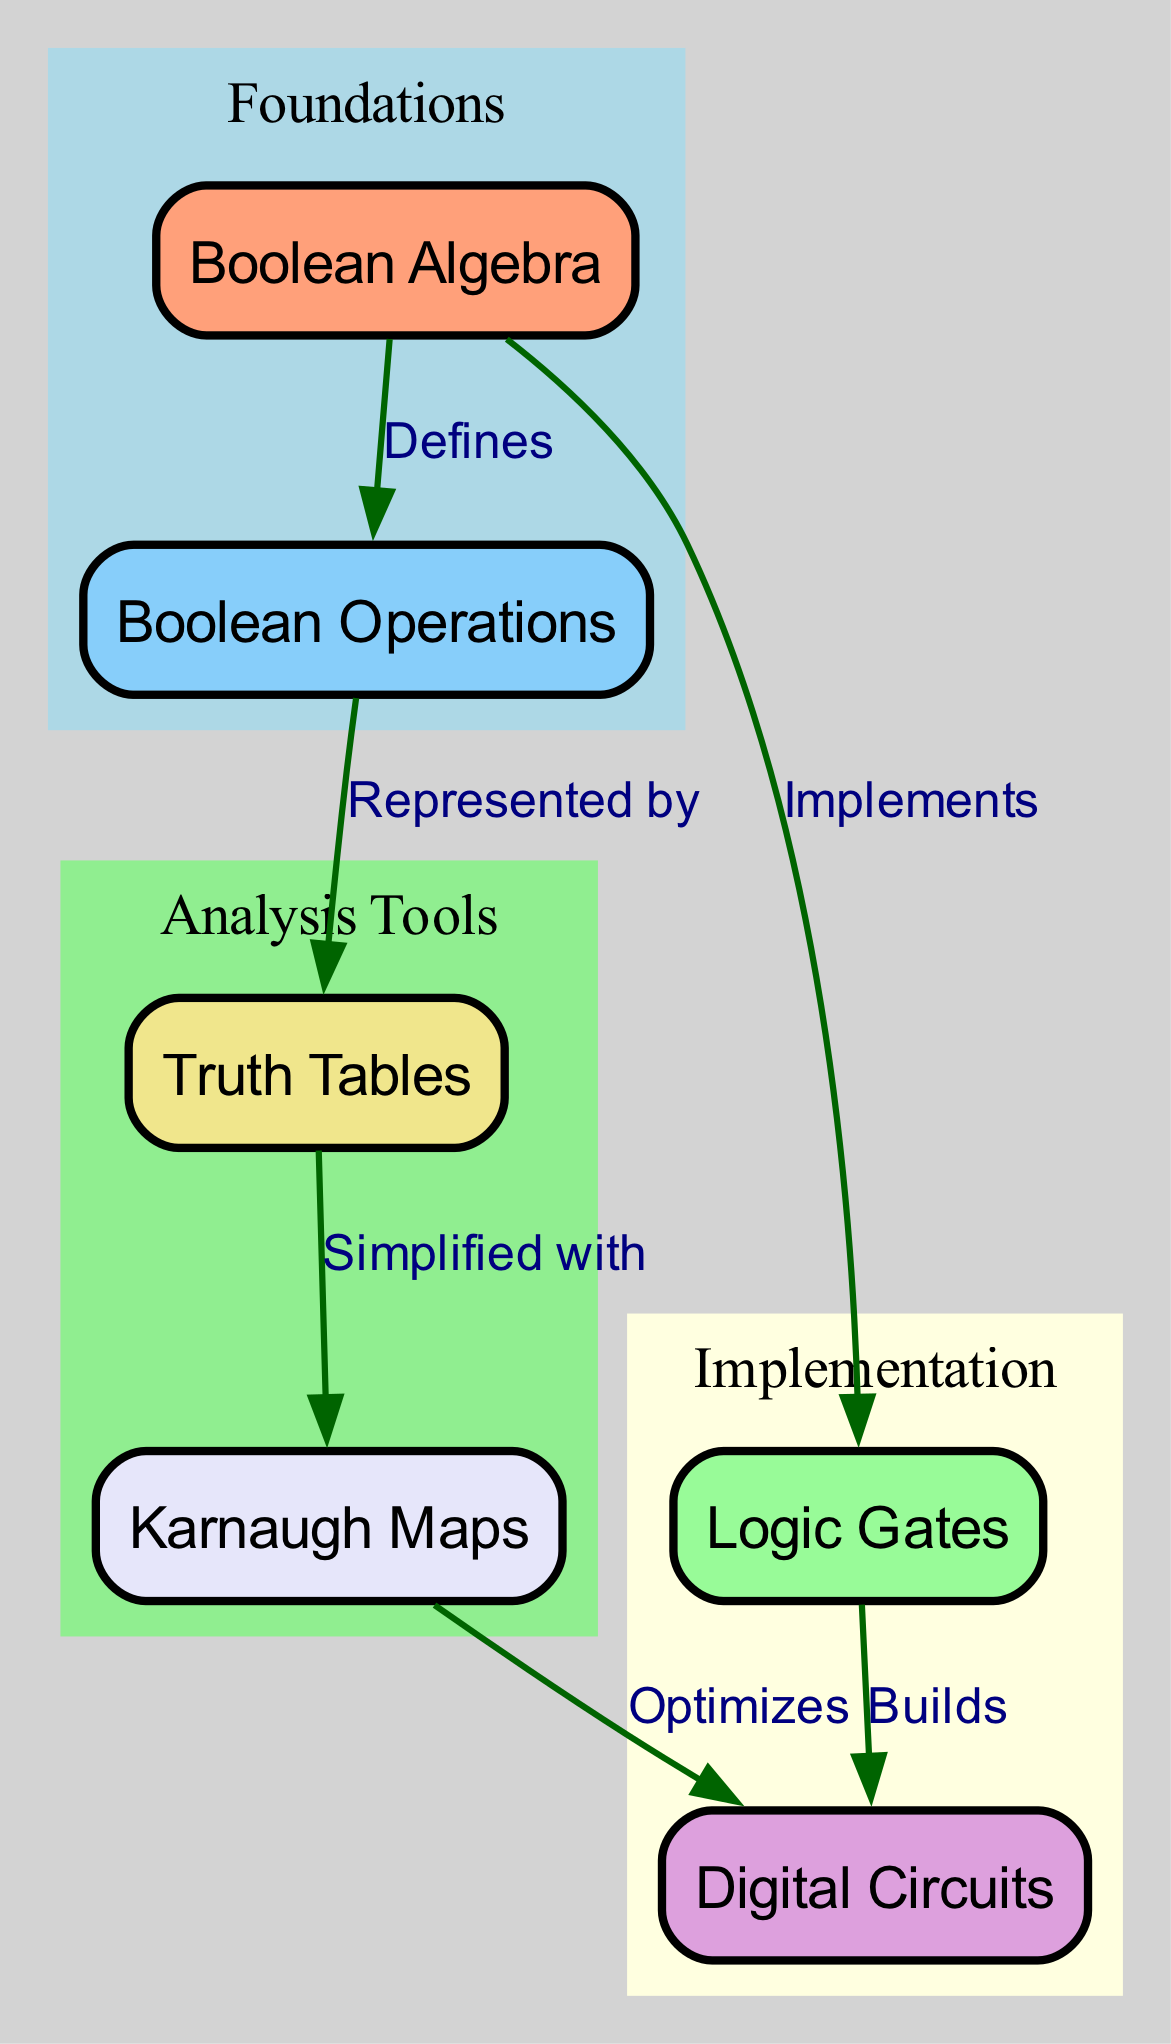What are the nodes in this diagram? The diagram presents multiple nodes, which are distinct entities representing concepts in Boolean algebra and digital circuit design. These nodes are: Boolean Algebra, Logic Gates, Boolean Operations, Digital Circuits, Truth Tables, and Karnaugh Maps.
Answer: Boolean Algebra, Logic Gates, Boolean Operations, Digital Circuits, Truth Tables, Karnaugh Maps How many edges are in the diagram? The diagram contains connections between the nodes, represented as edges. By examining the edges, we see there are a total of five edges connecting the various nodes as follows: Boolean Algebra to Logic Gates, Boolean Algebra to Boolean Operations, Logic Gates to Digital Circuits, Boolean Operations to Truth Tables, and Truth Tables to Karnaugh Maps.
Answer: Five Which node represents the foundational concept? In the diagram, the "Boolean Algebra" node is positioned at the beginning and is labeled as a foundational concept, as it defines other operations and implements logic gates. Therefore, it is correct to identify this node as the foundational concept in the context of digital circuit design.
Answer: Boolean Algebra What does the "Boolean Operations" node represent? The "Boolean Operations" node is connected to the "Boolean Algebra" node with the label "Defines," indicating it incorporates the definition of operations like AND, OR, NOT, etc. Furthermore, it is linked to the "Truth Tables" node with the label "Represented by," showing its role in depicting the outcomes of these operations.
Answer: Represents definitions of operations How do Karnaugh Maps interact with Digital Circuits? The diagram describes a flow where Karnaugh Maps optimize Digital Circuits. This is shown by the edge connecting the "Karnaugh Maps" node to the "Digital Circuits" node, indicating that simplification and optimization processes using Karnaugh Maps lead to more efficient designs in digital circuits.
Answer: Optimizes What is the relationship between Logic Gates and Digital Circuits? The relationship is direct as indicated in the diagram; Logic Gates are responsible for building Digital Circuits. This is clearly represented by the edge linking the "Logic Gates" node to the "Digital Circuits" node, which states "Builds."
Answer: Builds What can be simplified with Truth Tables? According to the diagram, Karnaugh Maps are used to simplify Truth Tables. The edge labeled "Simplified with" connects "Truth Tables" to "Karnaugh Maps," showing the method of simplification employed.
Answer: Karnaugh Maps How many clusters are present in the diagram? The diagram organizes nodes into three distinct clusters: Foundations, Implementation, and Analysis Tools. Each cluster groups related concepts, indicating an organized structure within the content of the diagram.
Answer: Three What node defines Boolean Operations? The "Boolean Algebra" node directly defines the "Boolean Operations." This connection is illustrated in the diagram through an edge that states "Defines," indicating the meaning and implications of various operations within Boolean algebra.
Answer: Boolean Algebra 